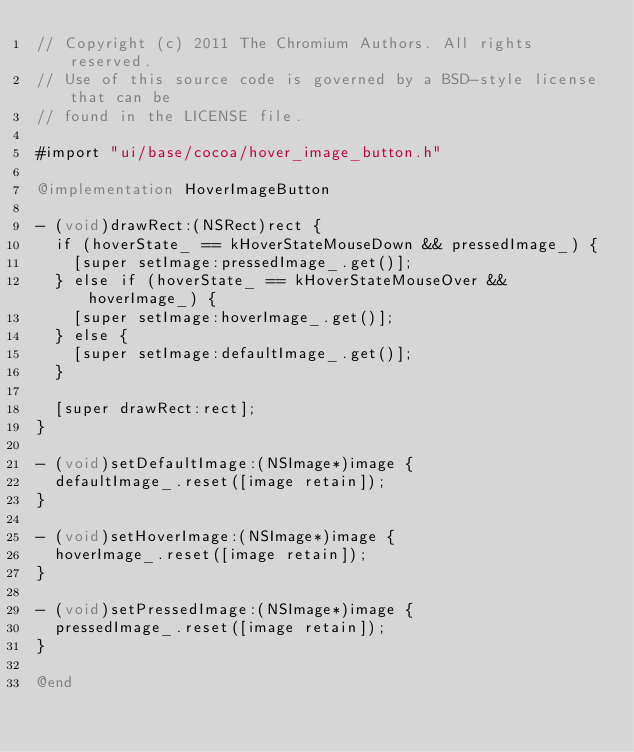<code> <loc_0><loc_0><loc_500><loc_500><_ObjectiveC_>// Copyright (c) 2011 The Chromium Authors. All rights reserved.
// Use of this source code is governed by a BSD-style license that can be
// found in the LICENSE file.

#import "ui/base/cocoa/hover_image_button.h"

@implementation HoverImageButton

- (void)drawRect:(NSRect)rect {
  if (hoverState_ == kHoverStateMouseDown && pressedImage_) {
    [super setImage:pressedImage_.get()];
  } else if (hoverState_ == kHoverStateMouseOver && hoverImage_) {
    [super setImage:hoverImage_.get()];
  } else {
    [super setImage:defaultImage_.get()];
  }

  [super drawRect:rect];
}

- (void)setDefaultImage:(NSImage*)image {
  defaultImage_.reset([image retain]);
}

- (void)setHoverImage:(NSImage*)image {
  hoverImage_.reset([image retain]);
}

- (void)setPressedImage:(NSImage*)image {
  pressedImage_.reset([image retain]);
}

@end
</code> 